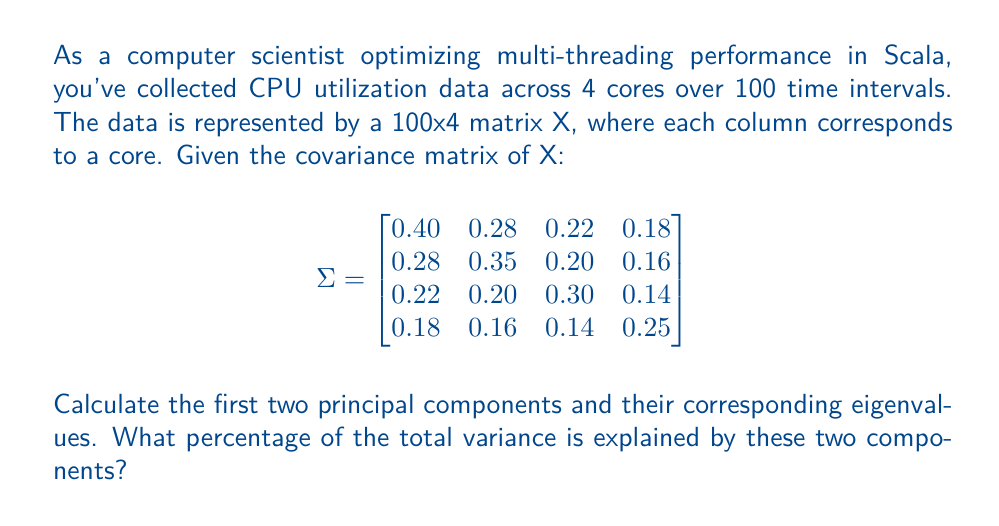Can you solve this math problem? To find the principal components and their corresponding eigenvalues, we need to follow these steps:

1) First, we need to find the eigenvalues of the covariance matrix Σ. We solve the characteristic equation:

   $$det(\Sigma - \lambda I) = 0$$

2) Solving this equation (which is a 4th degree polynomial) gives us the eigenvalues:

   $$\lambda_1 \approx 0.8962, \lambda_2 \approx 0.2238, \lambda_3 \approx 0.0978, \lambda_4 \approx 0.0822$$

3) The eigenvectors corresponding to these eigenvalues are the principal components. We can find them by solving:

   $$(\Sigma - \lambda_i I)v_i = 0$$

   for each $\lambda_i$

4) After normalization, the first two principal components (corresponding to the two largest eigenvalues) are approximately:

   $$PC_1 = [0.5754, 0.5162, 0.4570, 0.4386]^T$$
   $$PC_2 = [-0.0884, -0.2280, 0.2280, 0.9428]^T$$

5) To calculate the percentage of total variance explained by these two components:

   Total variance = sum of all eigenvalues = 0.8962 + 0.2238 + 0.0978 + 0.0822 = 1.3

   Percentage explained = $\frac{0.8962 + 0.2238}{1.3} \times 100\% \approx 86.15\%$
Answer: $PC_1 \approx [0.5754, 0.5162, 0.4570, 0.4386]^T$, $PC_2 \approx [-0.0884, -0.2280, 0.2280, 0.9428]^T$, $\lambda_1 \approx 0.8962$, $\lambda_2 \approx 0.2238$, 86.15% variance explained. 